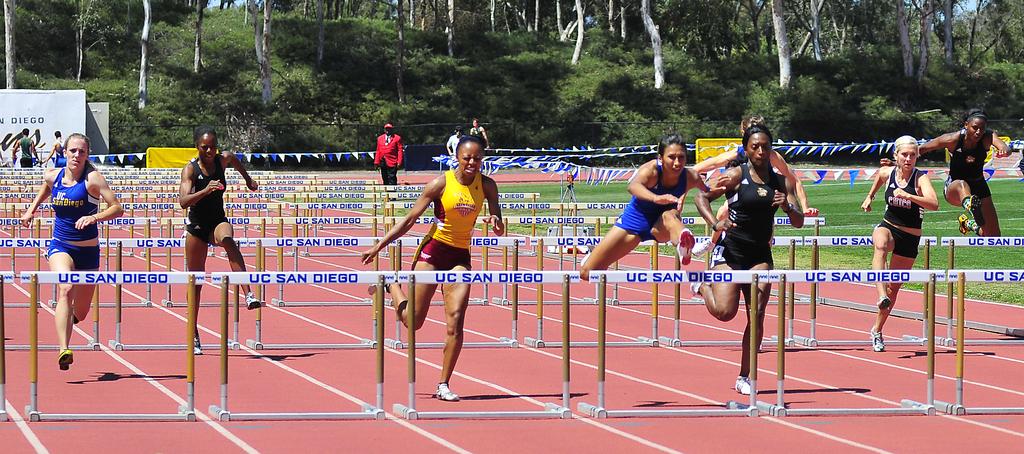Where is this taking place?
Make the answer very short. Uc san diego. 